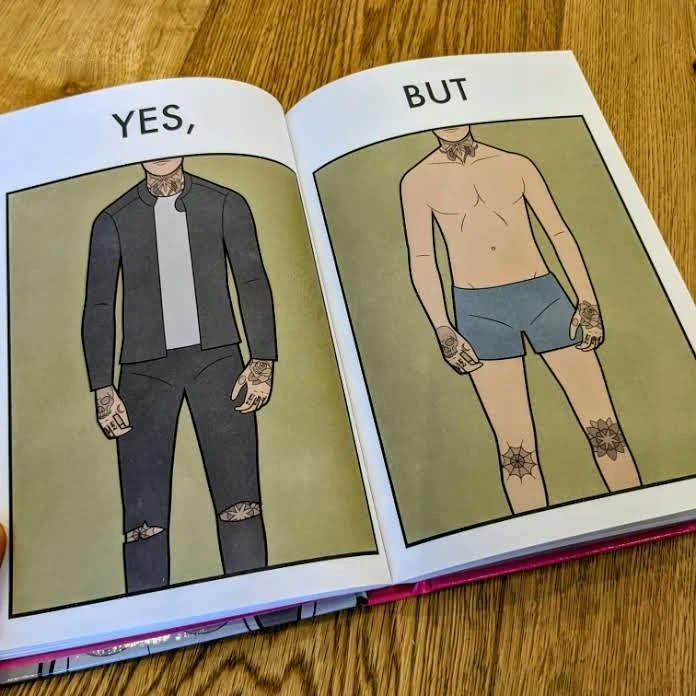What makes this image funny or satirical? The image is funny, as the person has made tattoos at places that are visible when wearing clothes, but look very awkward otherwise. 